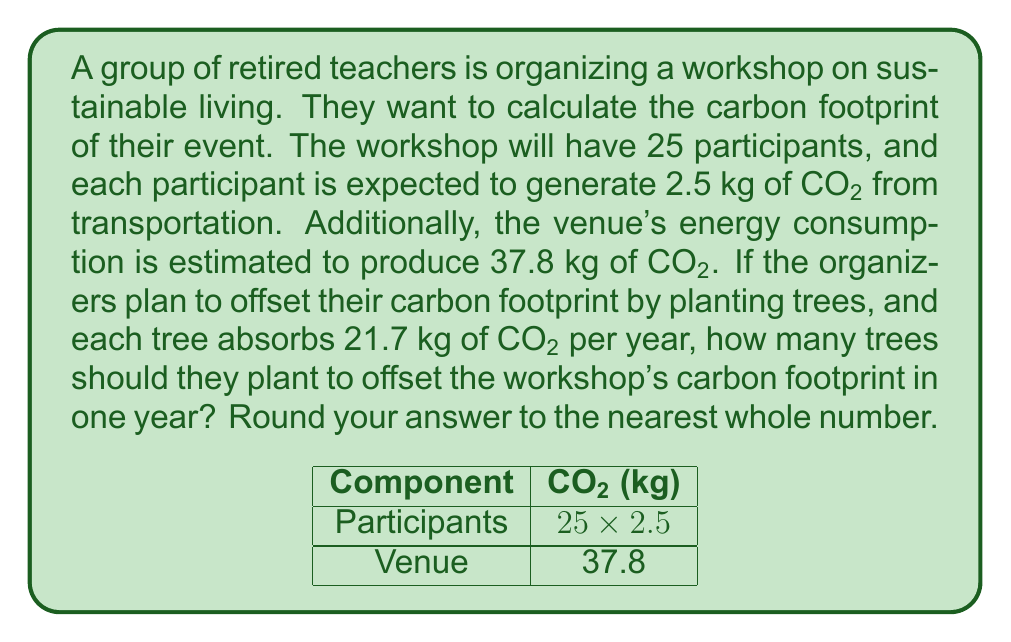Teach me how to tackle this problem. Let's break this down step-by-step using decimal arithmetic:

1. Calculate the total CO₂ produced by participants:
   $25 \text{ participants} \times 2.5 \text{ kg CO₂/participant} = 62.5 \text{ kg CO₂}$

2. Add the venue's CO₂ production:
   $62.5 \text{ kg CO₂} + 37.8 \text{ kg CO₂} = 100.3 \text{ kg CO₂}$

3. Calculate the number of trees needed:
   $\frac{100.3 \text{ kg CO₂}}{21.7 \text{ kg CO₂/tree}} \approx 4.6221198156682$

4. Round to the nearest whole number:
   $4.6221198156682 \approx 5 \text{ trees}$

Therefore, the organizers should plant 5 trees to offset the workshop's carbon footprint in one year.
Answer: 5 trees 